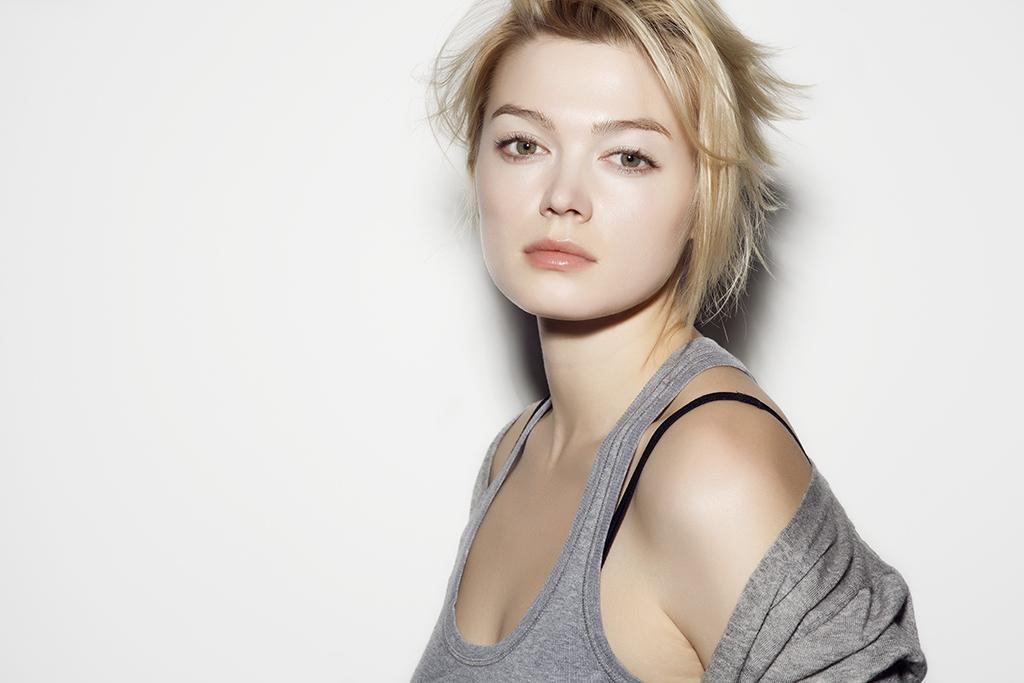Who is the main subject in the image? There is a lady in the image. What can be seen behind the lady? The background of the image is white. Where is the lady's son sitting during lunchtime in the image? There is no mention of a son or lunchtime in the image, so we cannot answer that question. 